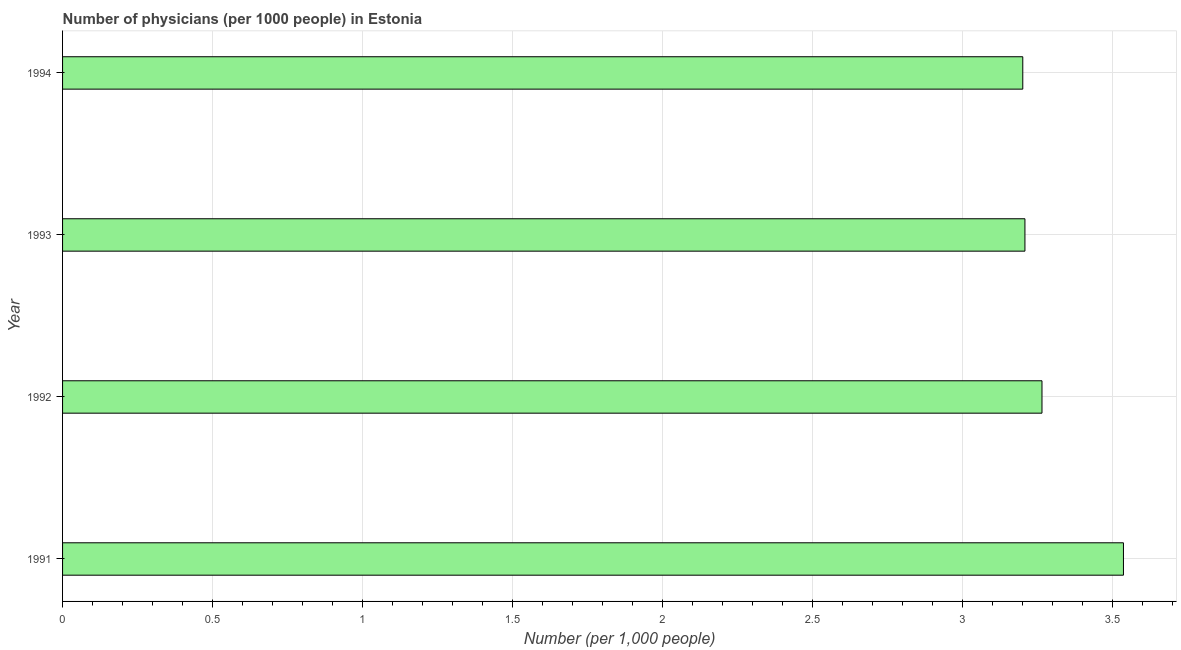What is the title of the graph?
Your response must be concise. Number of physicians (per 1000 people) in Estonia. What is the label or title of the X-axis?
Ensure brevity in your answer.  Number (per 1,0 people). What is the number of physicians in 1994?
Offer a very short reply. 3.2. Across all years, what is the maximum number of physicians?
Offer a terse response. 3.54. Across all years, what is the minimum number of physicians?
Your response must be concise. 3.2. In which year was the number of physicians minimum?
Offer a very short reply. 1994. What is the sum of the number of physicians?
Make the answer very short. 13.21. What is the difference between the number of physicians in 1992 and 1994?
Keep it short and to the point. 0.06. What is the average number of physicians per year?
Offer a very short reply. 3.3. What is the median number of physicians?
Your answer should be very brief. 3.24. In how many years, is the number of physicians greater than 0.6 ?
Your answer should be very brief. 4. Do a majority of the years between 1991 and 1994 (inclusive) have number of physicians greater than 3.4 ?
Provide a succinct answer. No. Is the number of physicians in 1991 less than that in 1994?
Your response must be concise. No. What is the difference between the highest and the second highest number of physicians?
Offer a terse response. 0.27. What is the difference between the highest and the lowest number of physicians?
Provide a succinct answer. 0.34. In how many years, is the number of physicians greater than the average number of physicians taken over all years?
Offer a very short reply. 1. Are all the bars in the graph horizontal?
Make the answer very short. Yes. How many years are there in the graph?
Give a very brief answer. 4. Are the values on the major ticks of X-axis written in scientific E-notation?
Your answer should be compact. No. What is the Number (per 1,000 people) in 1991?
Your answer should be compact. 3.54. What is the Number (per 1,000 people) in 1992?
Provide a short and direct response. 3.26. What is the Number (per 1,000 people) in 1993?
Make the answer very short. 3.21. What is the Number (per 1,000 people) of 1994?
Provide a succinct answer. 3.2. What is the difference between the Number (per 1,000 people) in 1991 and 1992?
Offer a terse response. 0.27. What is the difference between the Number (per 1,000 people) in 1991 and 1993?
Offer a very short reply. 0.33. What is the difference between the Number (per 1,000 people) in 1991 and 1994?
Your response must be concise. 0.34. What is the difference between the Number (per 1,000 people) in 1992 and 1993?
Keep it short and to the point. 0.06. What is the difference between the Number (per 1,000 people) in 1992 and 1994?
Your response must be concise. 0.06. What is the difference between the Number (per 1,000 people) in 1993 and 1994?
Give a very brief answer. 0.01. What is the ratio of the Number (per 1,000 people) in 1991 to that in 1992?
Provide a succinct answer. 1.08. What is the ratio of the Number (per 1,000 people) in 1991 to that in 1993?
Provide a succinct answer. 1.1. What is the ratio of the Number (per 1,000 people) in 1991 to that in 1994?
Ensure brevity in your answer.  1.1. 